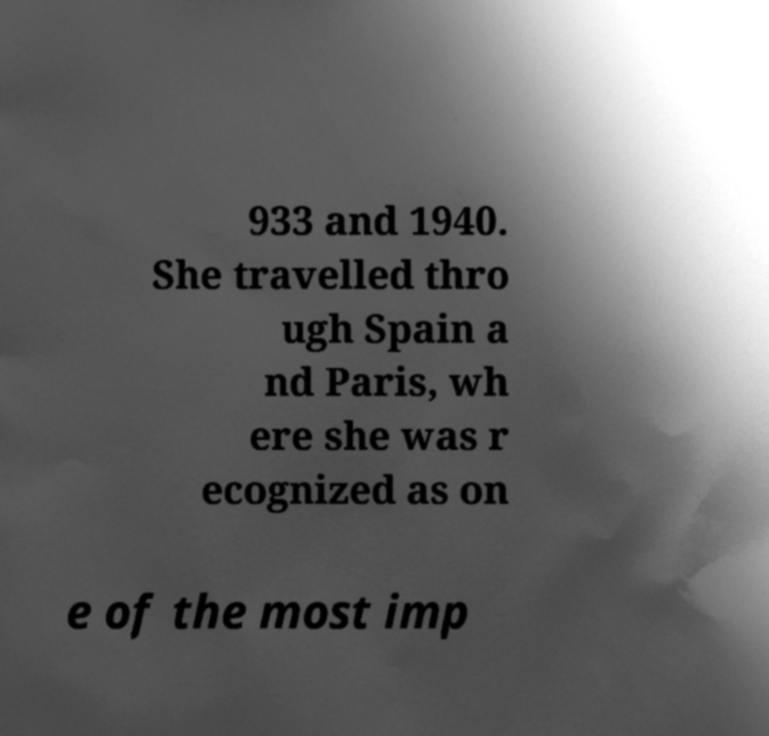Can you read and provide the text displayed in the image?This photo seems to have some interesting text. Can you extract and type it out for me? 933 and 1940. She travelled thro ugh Spain a nd Paris, wh ere she was r ecognized as on e of the most imp 